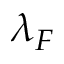Convert formula to latex. <formula><loc_0><loc_0><loc_500><loc_500>\lambda _ { F }</formula> 